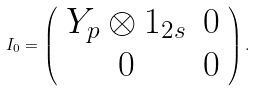<formula> <loc_0><loc_0><loc_500><loc_500>I _ { 0 } = \left ( \begin{array} { c c } Y _ { p } \otimes { 1 } _ { 2 s } & 0 \\ 0 & 0 \end{array} \right ) .</formula> 